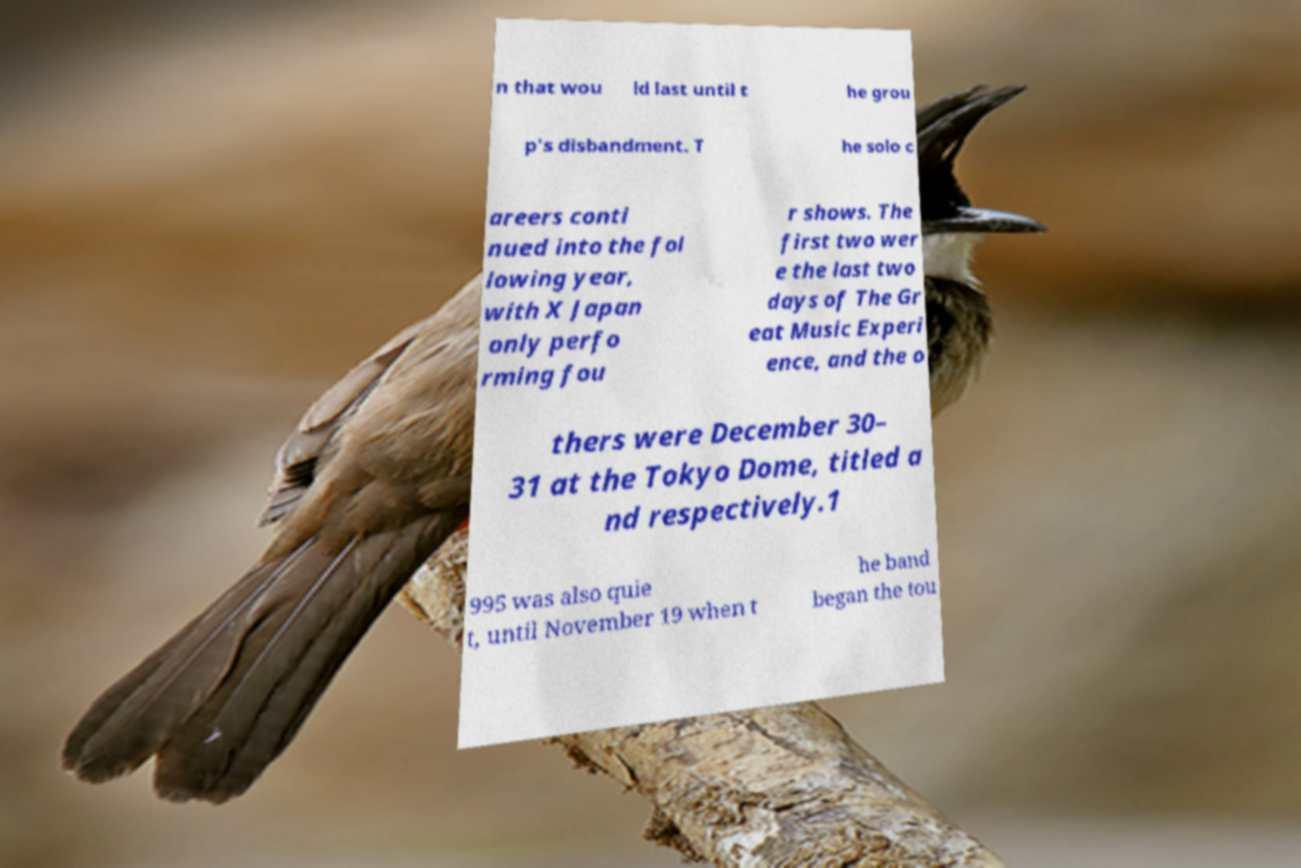What messages or text are displayed in this image? I need them in a readable, typed format. n that wou ld last until t he grou p's disbandment. T he solo c areers conti nued into the fol lowing year, with X Japan only perfo rming fou r shows. The first two wer e the last two days of The Gr eat Music Experi ence, and the o thers were December 30– 31 at the Tokyo Dome, titled a nd respectively.1 995 was also quie t, until November 19 when t he band began the tou 